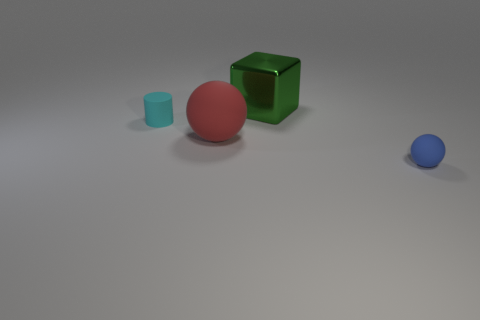Add 4 yellow metallic things. How many objects exist? 8 Subtract all cylinders. How many objects are left? 3 Subtract 0 red cylinders. How many objects are left? 4 Subtract all tiny matte cylinders. Subtract all cyan objects. How many objects are left? 2 Add 3 small rubber balls. How many small rubber balls are left? 4 Add 3 small cyan rubber cylinders. How many small cyan rubber cylinders exist? 4 